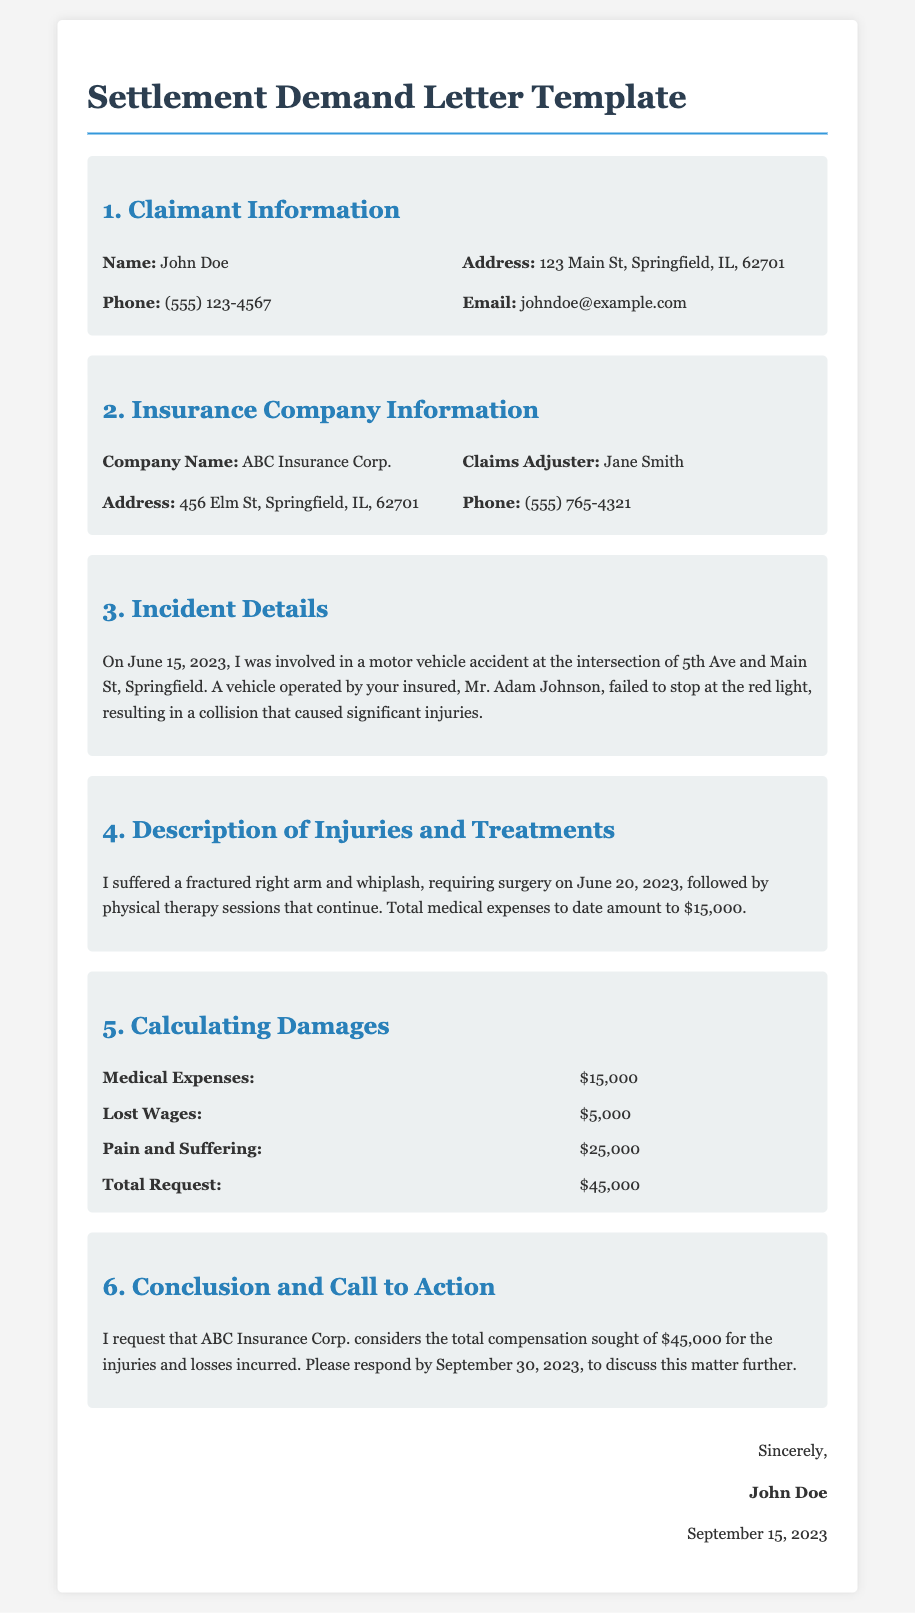What is the claimant's name? The claimant's name is found in the "Claimant Information" section of the document.
Answer: John Doe What is the date of the incident? The date of the incident is mentioned in the "Incident Details" section of the document.
Answer: June 15, 2023 What is the total medical expenses incurred? The total medical expenses are listed in the "Calculating Damages" section of the document.
Answer: $15,000 Who is the claims adjuster? The claims adjuster's name is provided in the "Insurance Company Information" section of the document.
Answer: Jane Smith What is the total compensation requested? The total compensation requested is specified in the "Calculating Damages" section of the document.
Answer: $45,000 What type of injury did the claimant suffer? The type of injury suffered is indicated in the "Description of Injuries and Treatments" section.
Answer: Fractured right arm and whiplash By what date should the insurance company respond? The deadline for the insurance company's response is mentioned in the "Conclusion and Call to Action" section.
Answer: September 30, 2023 